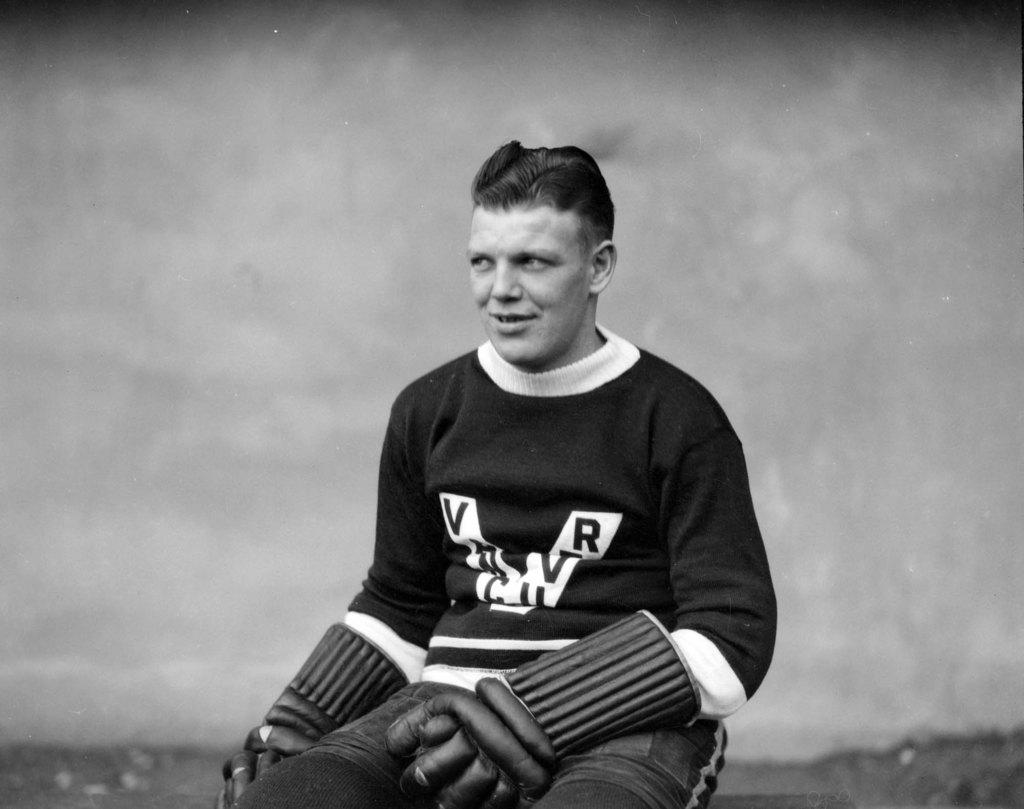<image>
Share a concise interpretation of the image provided. An athlete wearing a jersey with the letters V and R on it. 